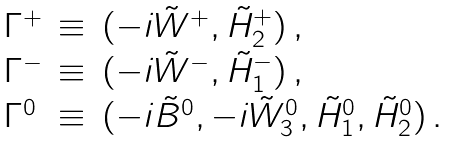<formula> <loc_0><loc_0><loc_500><loc_500>\begin{array} { l c l } \Gamma ^ { + } & \equiv & ( - i \tilde { W } ^ { + } , \tilde { H } _ { 2 } ^ { + } ) \, , \\ \Gamma ^ { - } & \equiv & ( - i \tilde { W } ^ { - } , \tilde { H } _ { 1 } ^ { - } ) \, , \\ \Gamma ^ { 0 } & \equiv & ( - i \tilde { B } ^ { 0 } , - i \tilde { W } _ { 3 } ^ { 0 } , \tilde { H } _ { 1 } ^ { 0 } , \tilde { H } _ { 2 } ^ { 0 } ) \, . \end{array}</formula> 